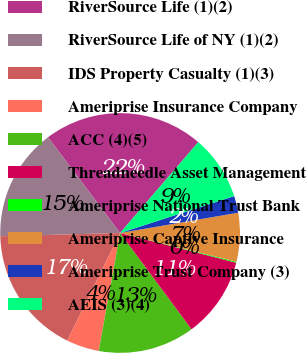Convert chart to OTSL. <chart><loc_0><loc_0><loc_500><loc_500><pie_chart><fcel>RiverSource Life (1)(2)<fcel>RiverSource Life of NY (1)(2)<fcel>IDS Property Casualty (1)(3)<fcel>Ameriprise Insurance Company<fcel>ACC (4)(5)<fcel>Threadneedle Asset Management<fcel>Ameriprise National Trust Bank<fcel>Ameriprise Captive Insurance<fcel>Ameriprise Trust Company (3)<fcel>AEIS (3)(4)<nl><fcel>21.59%<fcel>15.15%<fcel>17.3%<fcel>4.42%<fcel>13.01%<fcel>10.86%<fcel>0.13%<fcel>6.57%<fcel>2.27%<fcel>8.71%<nl></chart> 